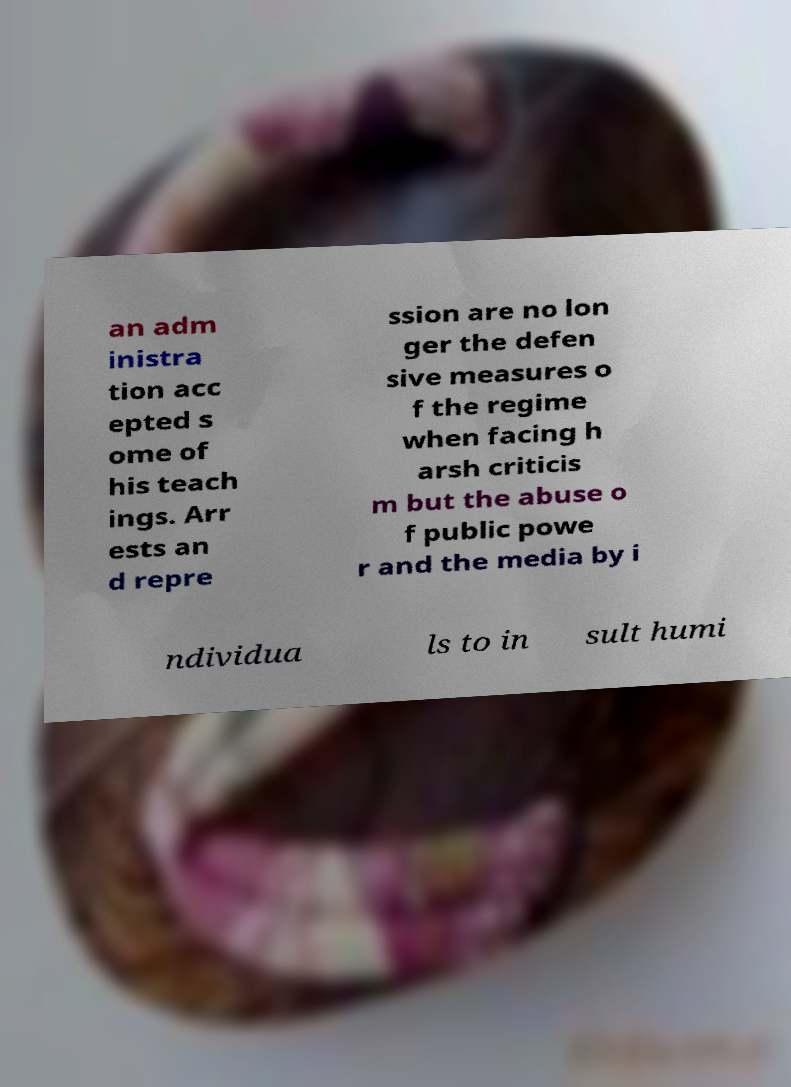There's text embedded in this image that I need extracted. Can you transcribe it verbatim? an adm inistra tion acc epted s ome of his teach ings. Arr ests an d repre ssion are no lon ger the defen sive measures o f the regime when facing h arsh criticis m but the abuse o f public powe r and the media by i ndividua ls to in sult humi 